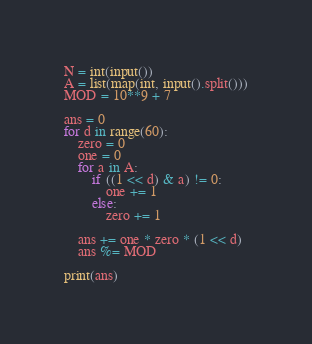Convert code to text. <code><loc_0><loc_0><loc_500><loc_500><_Python_>N = int(input())
A = list(map(int, input().split()))
MOD = 10**9 + 7

ans = 0
for d in range(60):
    zero = 0
    one = 0
    for a in A:
        if ((1 << d) & a) != 0:
            one += 1
        else:
            zero += 1

    ans += one * zero * (1 << d)
    ans %= MOD

print(ans)
</code> 